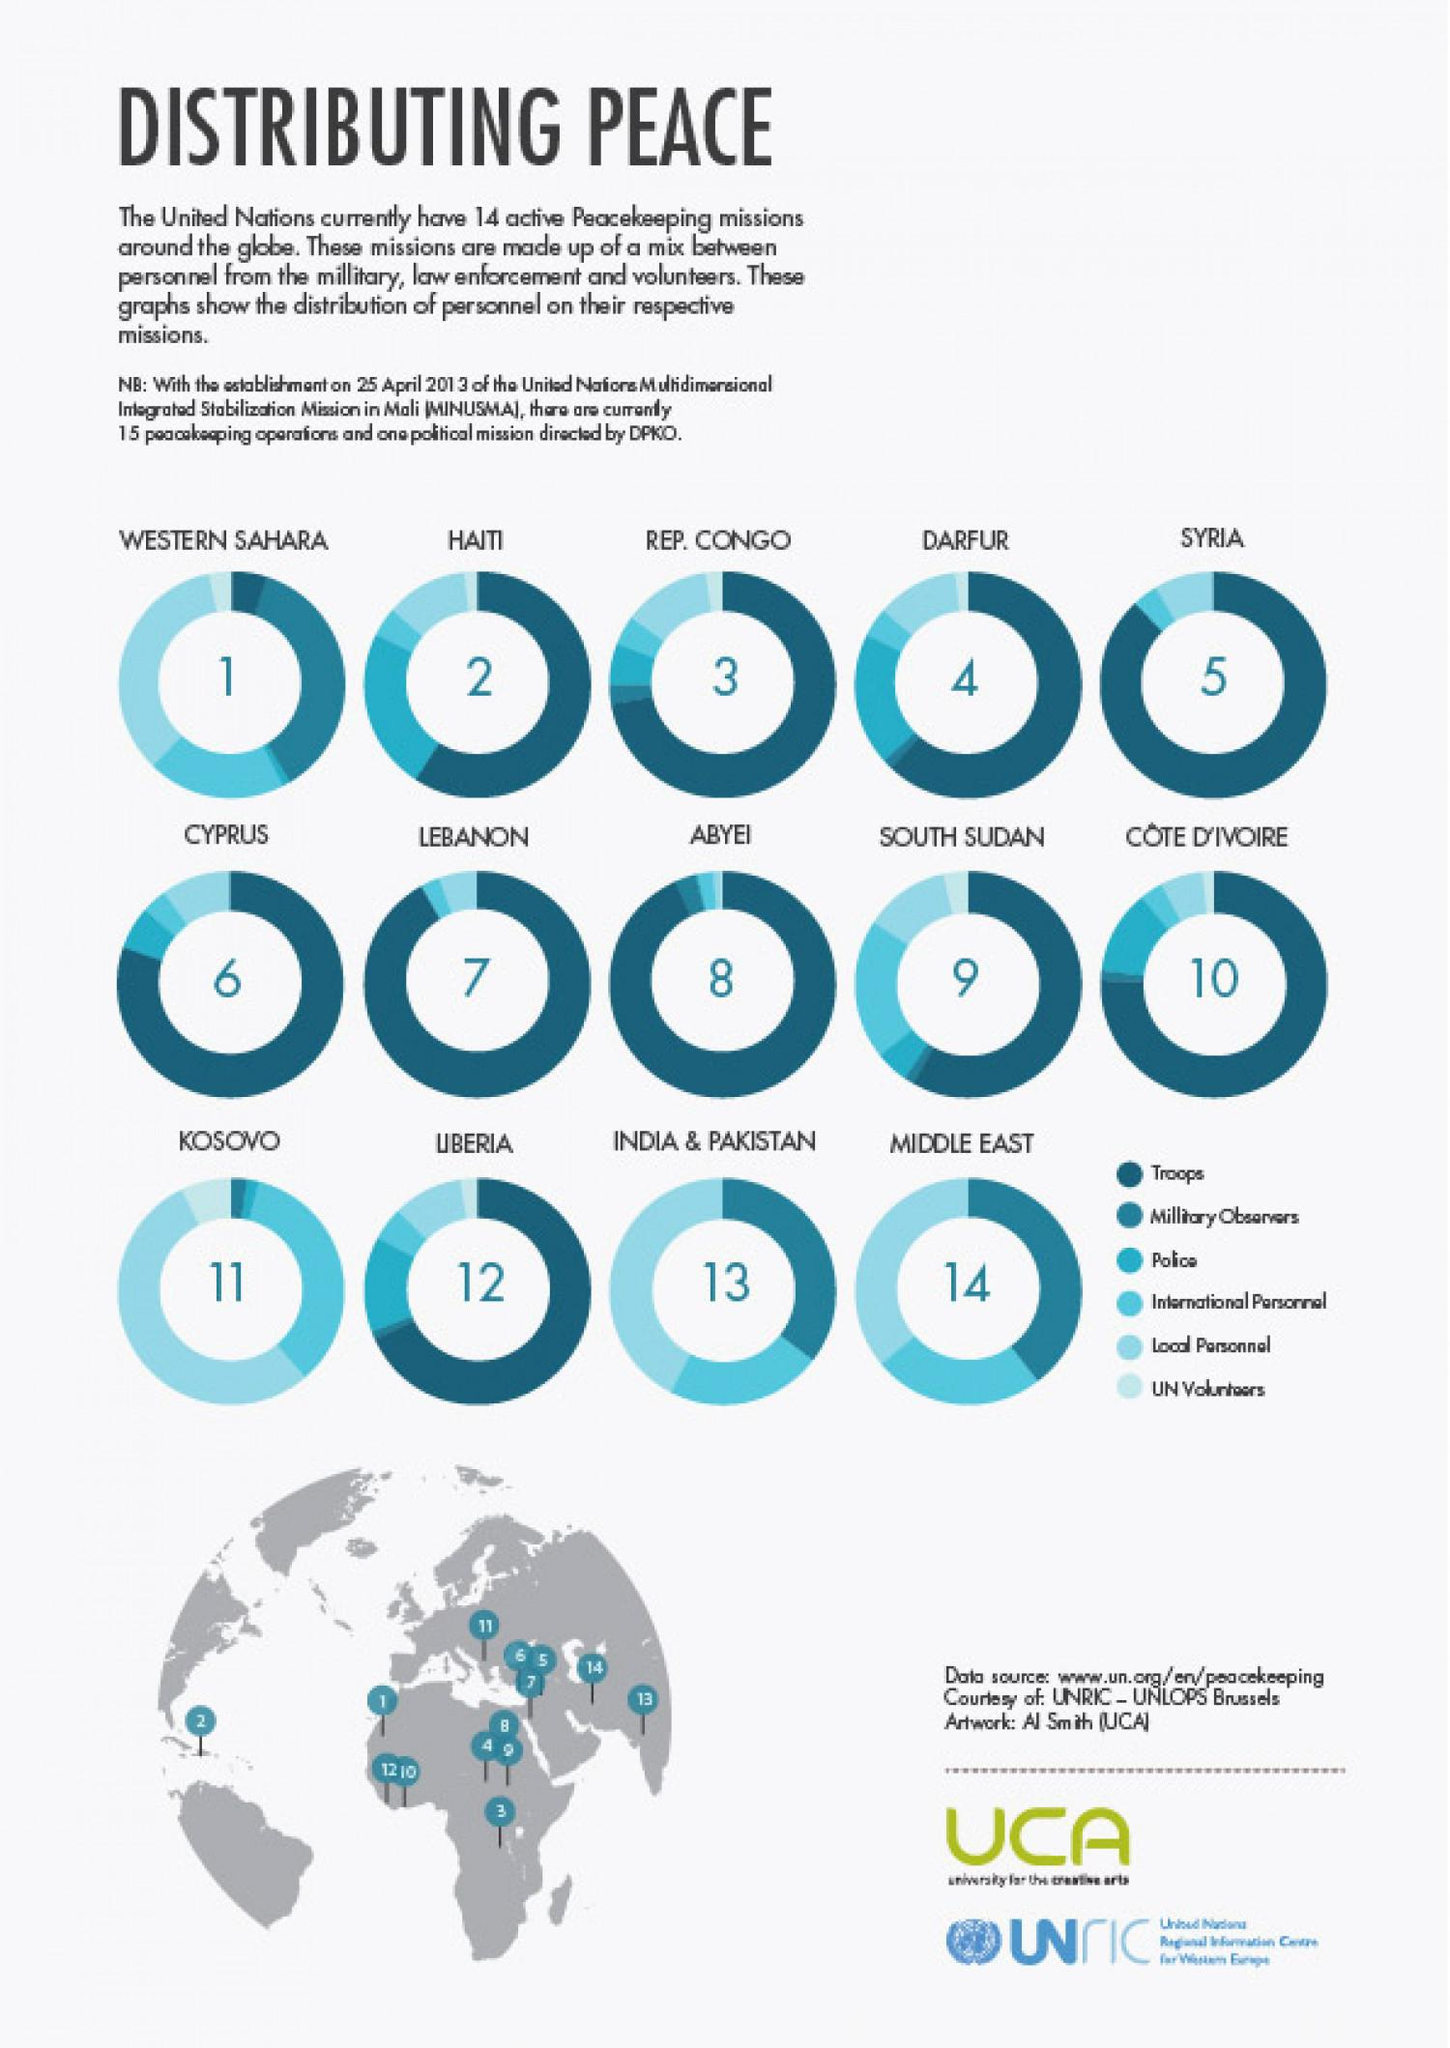Outline some significant characteristics in this image. The Kosovo peace mission has the lowest proportion of troops and military observers among its personnel, indicating a greater emphasis on civilian personnel in promoting peace and stability. India and Pakistan are the two Asian countries where the United Nations has a single common peacekeeping mission. In Liberia, it is troops who have the highest share of personnel. According to the provided map, Africa has the highest number of United Nations peacekeeping missions, with the majority of these missions taking place in the continent's countries. 